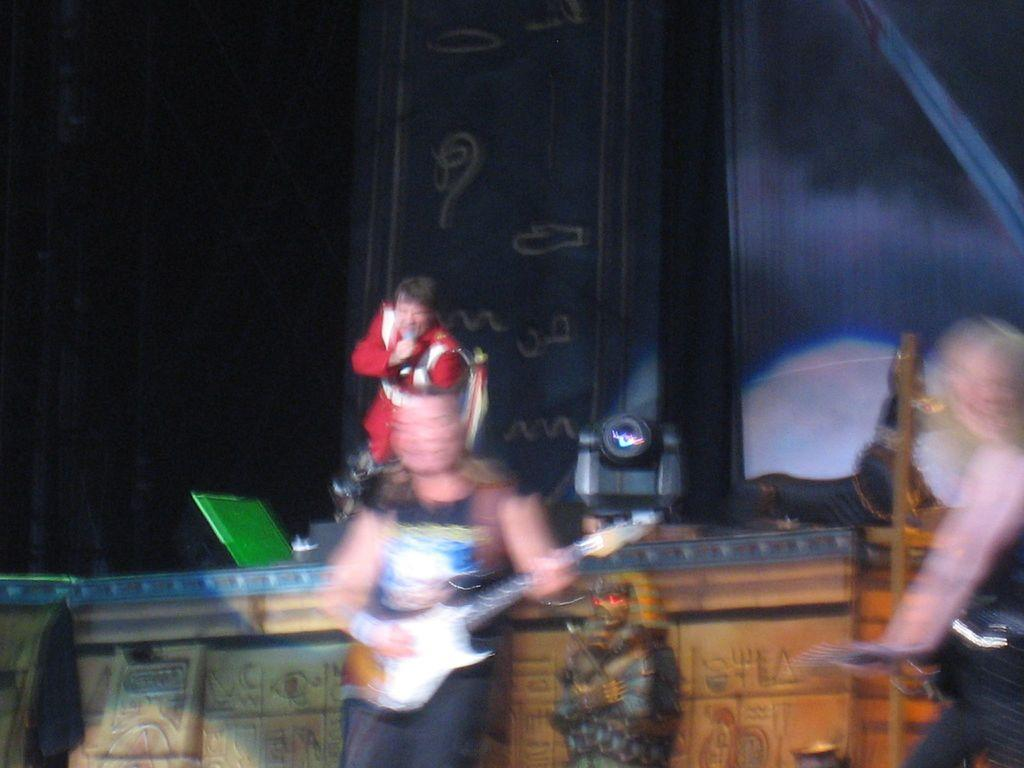How many people are in the image? There are four people in the image. What are two of the people doing? One person is playing a guitar, and another person is singing. Where are the guitar player and the singer located? Both the guitar player and the singer are on a stage. What can be seen in the background behind the stage? There are black sheets and lights in the background. Can you hear the sound of the sea in the background of the image? There is no sound present in the image, and the image does not depict any sea or ocean. 